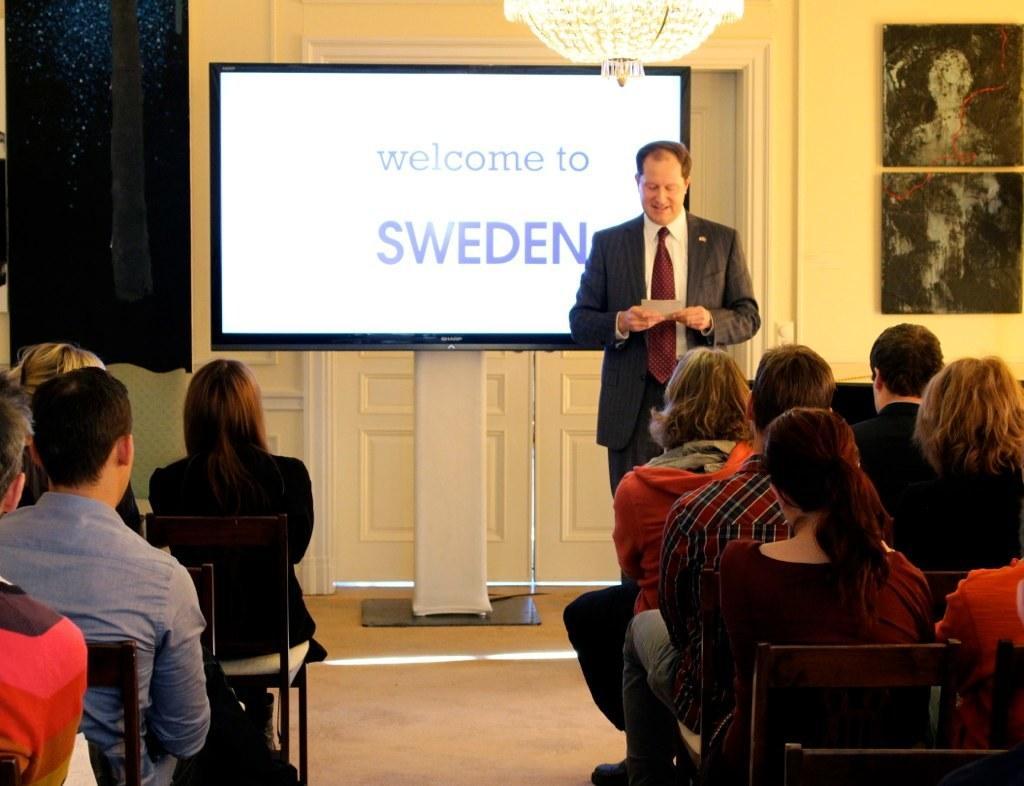Describe this image in one or two sentences. In this image there is a person holding a paper. He is standing on the floor. He is wearing a blazer and tie. There is a screen on the stand. On the screen there is some text. There are picture frames attached to the wall having doors. Bottom of the image there are people sitting on the chairs. Left side there is a curtain. Top of the image there is a chandelier. 